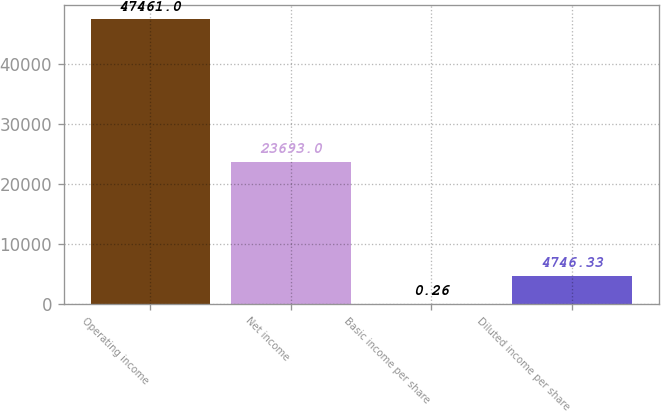<chart> <loc_0><loc_0><loc_500><loc_500><bar_chart><fcel>Operating income<fcel>Net income<fcel>Basic income per share<fcel>Diluted income per share<nl><fcel>47461<fcel>23693<fcel>0.26<fcel>4746.33<nl></chart> 